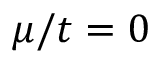<formula> <loc_0><loc_0><loc_500><loc_500>\mu / t = 0</formula> 